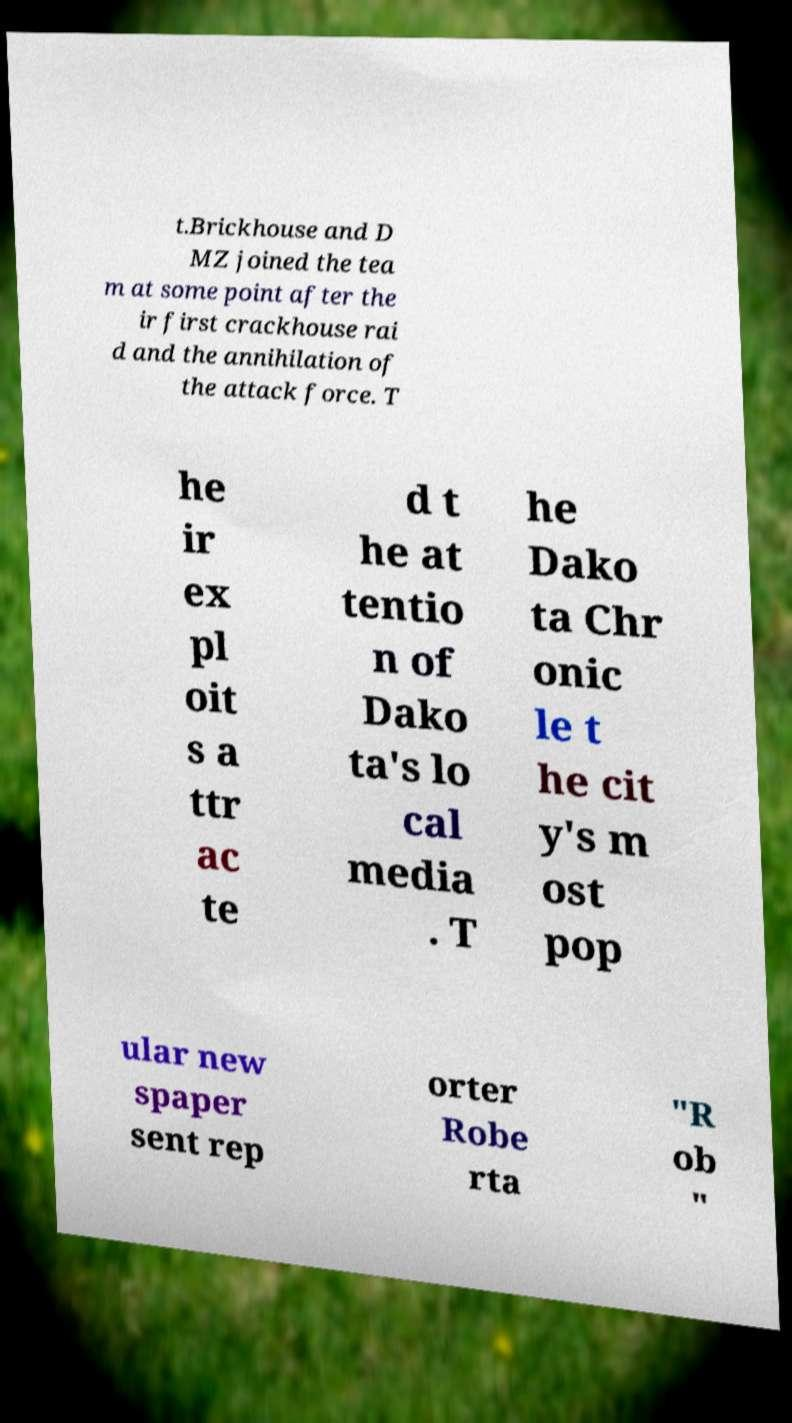What messages or text are displayed in this image? I need them in a readable, typed format. t.Brickhouse and D MZ joined the tea m at some point after the ir first crackhouse rai d and the annihilation of the attack force. T he ir ex pl oit s a ttr ac te d t he at tentio n of Dako ta's lo cal media . T he Dako ta Chr onic le t he cit y's m ost pop ular new spaper sent rep orter Robe rta "R ob " 